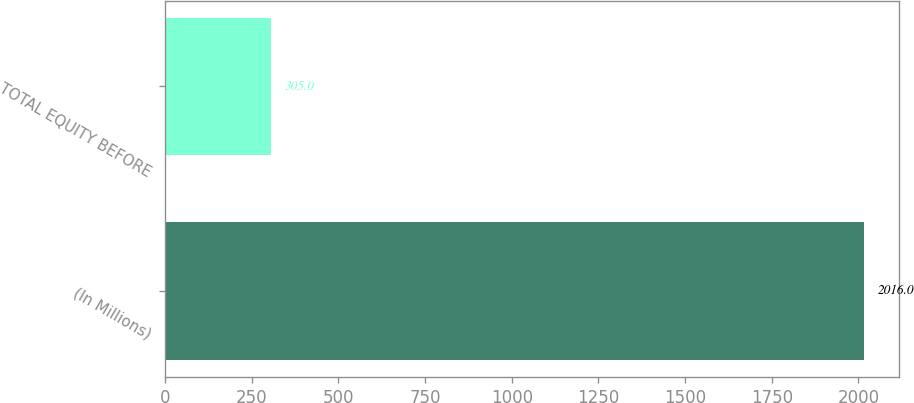<chart> <loc_0><loc_0><loc_500><loc_500><bar_chart><fcel>(In Millions)<fcel>TOTAL EQUITY BEFORE<nl><fcel>2016<fcel>305<nl></chart> 